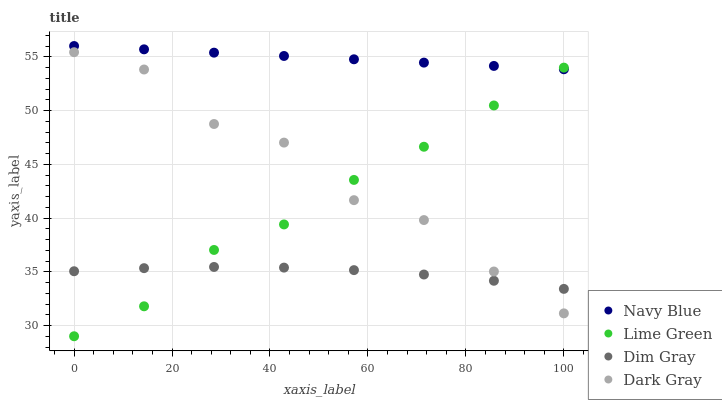Does Dim Gray have the minimum area under the curve?
Answer yes or no. Yes. Does Navy Blue have the maximum area under the curve?
Answer yes or no. Yes. Does Navy Blue have the minimum area under the curve?
Answer yes or no. No. Does Dim Gray have the maximum area under the curve?
Answer yes or no. No. Is Navy Blue the smoothest?
Answer yes or no. Yes. Is Dark Gray the roughest?
Answer yes or no. Yes. Is Dim Gray the smoothest?
Answer yes or no. No. Is Dim Gray the roughest?
Answer yes or no. No. Does Lime Green have the lowest value?
Answer yes or no. Yes. Does Dim Gray have the lowest value?
Answer yes or no. No. Does Navy Blue have the highest value?
Answer yes or no. Yes. Does Dim Gray have the highest value?
Answer yes or no. No. Is Dark Gray less than Navy Blue?
Answer yes or no. Yes. Is Navy Blue greater than Dim Gray?
Answer yes or no. Yes. Does Lime Green intersect Dim Gray?
Answer yes or no. Yes. Is Lime Green less than Dim Gray?
Answer yes or no. No. Is Lime Green greater than Dim Gray?
Answer yes or no. No. Does Dark Gray intersect Navy Blue?
Answer yes or no. No. 